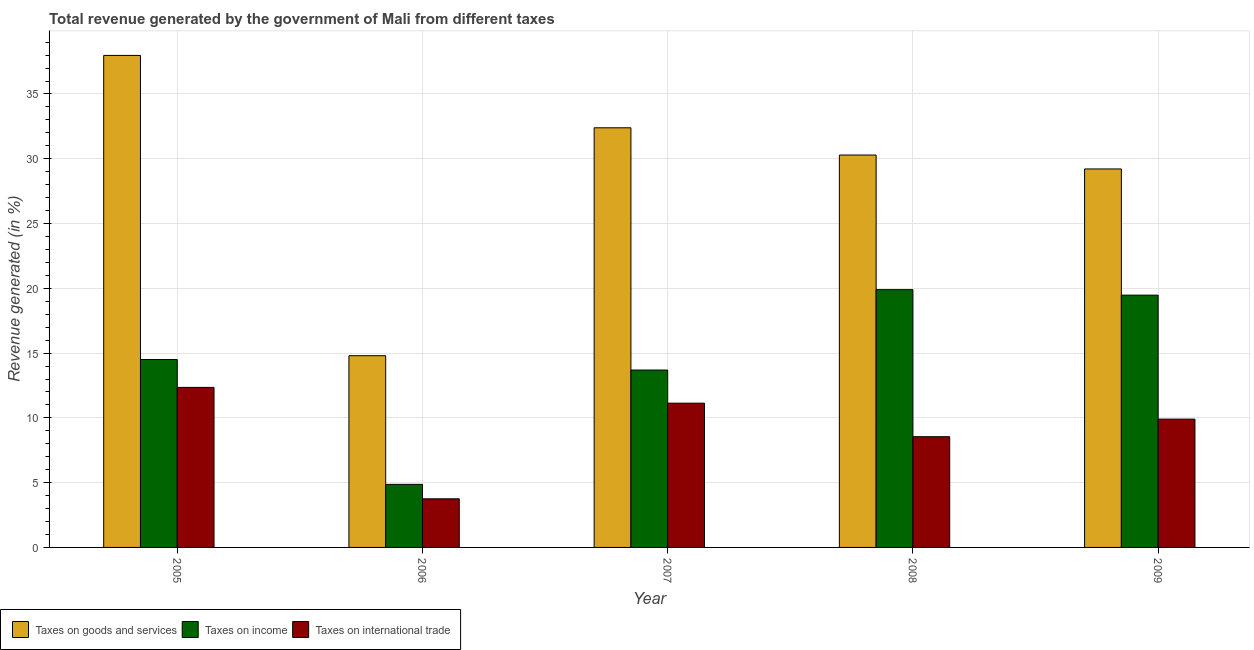How many different coloured bars are there?
Provide a short and direct response. 3. How many groups of bars are there?
Give a very brief answer. 5. Are the number of bars per tick equal to the number of legend labels?
Provide a short and direct response. Yes. Are the number of bars on each tick of the X-axis equal?
Offer a terse response. Yes. How many bars are there on the 4th tick from the left?
Your answer should be compact. 3. What is the label of the 3rd group of bars from the left?
Make the answer very short. 2007. What is the percentage of revenue generated by taxes on income in 2007?
Keep it short and to the point. 13.69. Across all years, what is the maximum percentage of revenue generated by taxes on income?
Ensure brevity in your answer.  19.9. Across all years, what is the minimum percentage of revenue generated by taxes on income?
Offer a very short reply. 4.87. In which year was the percentage of revenue generated by taxes on goods and services minimum?
Your response must be concise. 2006. What is the total percentage of revenue generated by taxes on income in the graph?
Provide a succinct answer. 72.44. What is the difference between the percentage of revenue generated by taxes on goods and services in 2006 and that in 2009?
Keep it short and to the point. -14.42. What is the difference between the percentage of revenue generated by taxes on income in 2007 and the percentage of revenue generated by taxes on goods and services in 2009?
Ensure brevity in your answer.  -5.78. What is the average percentage of revenue generated by taxes on goods and services per year?
Provide a short and direct response. 28.93. In the year 2006, what is the difference between the percentage of revenue generated by taxes on goods and services and percentage of revenue generated by tax on international trade?
Give a very brief answer. 0. What is the ratio of the percentage of revenue generated by taxes on goods and services in 2007 to that in 2009?
Your answer should be very brief. 1.11. What is the difference between the highest and the second highest percentage of revenue generated by taxes on goods and services?
Ensure brevity in your answer.  5.59. What is the difference between the highest and the lowest percentage of revenue generated by taxes on income?
Ensure brevity in your answer.  15.03. In how many years, is the percentage of revenue generated by tax on international trade greater than the average percentage of revenue generated by tax on international trade taken over all years?
Provide a short and direct response. 3. Is the sum of the percentage of revenue generated by taxes on goods and services in 2006 and 2009 greater than the maximum percentage of revenue generated by tax on international trade across all years?
Ensure brevity in your answer.  Yes. What does the 1st bar from the left in 2009 represents?
Provide a short and direct response. Taxes on goods and services. What does the 3rd bar from the right in 2006 represents?
Offer a very short reply. Taxes on goods and services. How many bars are there?
Offer a very short reply. 15. How many years are there in the graph?
Make the answer very short. 5. What is the difference between two consecutive major ticks on the Y-axis?
Your answer should be very brief. 5. Does the graph contain grids?
Give a very brief answer. Yes. Where does the legend appear in the graph?
Your answer should be very brief. Bottom left. How many legend labels are there?
Provide a succinct answer. 3. What is the title of the graph?
Make the answer very short. Total revenue generated by the government of Mali from different taxes. Does "Neonatal" appear as one of the legend labels in the graph?
Make the answer very short. No. What is the label or title of the X-axis?
Provide a short and direct response. Year. What is the label or title of the Y-axis?
Your answer should be compact. Revenue generated (in %). What is the Revenue generated (in %) in Taxes on goods and services in 2005?
Your response must be concise. 37.98. What is the Revenue generated (in %) of Taxes on income in 2005?
Make the answer very short. 14.51. What is the Revenue generated (in %) in Taxes on international trade in 2005?
Offer a terse response. 12.35. What is the Revenue generated (in %) of Taxes on goods and services in 2006?
Your answer should be very brief. 14.8. What is the Revenue generated (in %) of Taxes on income in 2006?
Give a very brief answer. 4.87. What is the Revenue generated (in %) in Taxes on international trade in 2006?
Provide a succinct answer. 3.75. What is the Revenue generated (in %) in Taxes on goods and services in 2007?
Your response must be concise. 32.39. What is the Revenue generated (in %) in Taxes on income in 2007?
Offer a terse response. 13.69. What is the Revenue generated (in %) in Taxes on international trade in 2007?
Provide a succinct answer. 11.14. What is the Revenue generated (in %) of Taxes on goods and services in 2008?
Provide a succinct answer. 30.29. What is the Revenue generated (in %) in Taxes on income in 2008?
Provide a succinct answer. 19.9. What is the Revenue generated (in %) in Taxes on international trade in 2008?
Ensure brevity in your answer.  8.55. What is the Revenue generated (in %) in Taxes on goods and services in 2009?
Ensure brevity in your answer.  29.21. What is the Revenue generated (in %) in Taxes on income in 2009?
Make the answer very short. 19.47. What is the Revenue generated (in %) in Taxes on international trade in 2009?
Your answer should be very brief. 9.9. Across all years, what is the maximum Revenue generated (in %) of Taxes on goods and services?
Ensure brevity in your answer.  37.98. Across all years, what is the maximum Revenue generated (in %) of Taxes on income?
Your answer should be very brief. 19.9. Across all years, what is the maximum Revenue generated (in %) in Taxes on international trade?
Your answer should be very brief. 12.35. Across all years, what is the minimum Revenue generated (in %) of Taxes on goods and services?
Provide a succinct answer. 14.8. Across all years, what is the minimum Revenue generated (in %) in Taxes on income?
Offer a very short reply. 4.87. Across all years, what is the minimum Revenue generated (in %) of Taxes on international trade?
Your answer should be very brief. 3.75. What is the total Revenue generated (in %) in Taxes on goods and services in the graph?
Keep it short and to the point. 144.67. What is the total Revenue generated (in %) of Taxes on income in the graph?
Offer a terse response. 72.44. What is the total Revenue generated (in %) in Taxes on international trade in the graph?
Ensure brevity in your answer.  45.69. What is the difference between the Revenue generated (in %) in Taxes on goods and services in 2005 and that in 2006?
Offer a terse response. 23.18. What is the difference between the Revenue generated (in %) of Taxes on income in 2005 and that in 2006?
Offer a terse response. 9.64. What is the difference between the Revenue generated (in %) in Taxes on international trade in 2005 and that in 2006?
Your answer should be very brief. 8.6. What is the difference between the Revenue generated (in %) in Taxes on goods and services in 2005 and that in 2007?
Offer a very short reply. 5.59. What is the difference between the Revenue generated (in %) of Taxes on income in 2005 and that in 2007?
Provide a short and direct response. 0.82. What is the difference between the Revenue generated (in %) in Taxes on international trade in 2005 and that in 2007?
Offer a terse response. 1.22. What is the difference between the Revenue generated (in %) of Taxes on goods and services in 2005 and that in 2008?
Offer a very short reply. 7.69. What is the difference between the Revenue generated (in %) of Taxes on income in 2005 and that in 2008?
Give a very brief answer. -5.39. What is the difference between the Revenue generated (in %) of Taxes on international trade in 2005 and that in 2008?
Give a very brief answer. 3.81. What is the difference between the Revenue generated (in %) of Taxes on goods and services in 2005 and that in 2009?
Your response must be concise. 8.76. What is the difference between the Revenue generated (in %) in Taxes on income in 2005 and that in 2009?
Your answer should be very brief. -4.97. What is the difference between the Revenue generated (in %) of Taxes on international trade in 2005 and that in 2009?
Offer a terse response. 2.45. What is the difference between the Revenue generated (in %) in Taxes on goods and services in 2006 and that in 2007?
Offer a terse response. -17.59. What is the difference between the Revenue generated (in %) of Taxes on income in 2006 and that in 2007?
Give a very brief answer. -8.82. What is the difference between the Revenue generated (in %) in Taxes on international trade in 2006 and that in 2007?
Offer a very short reply. -7.38. What is the difference between the Revenue generated (in %) of Taxes on goods and services in 2006 and that in 2008?
Ensure brevity in your answer.  -15.49. What is the difference between the Revenue generated (in %) of Taxes on income in 2006 and that in 2008?
Offer a very short reply. -15.03. What is the difference between the Revenue generated (in %) of Taxes on international trade in 2006 and that in 2008?
Provide a short and direct response. -4.79. What is the difference between the Revenue generated (in %) in Taxes on goods and services in 2006 and that in 2009?
Give a very brief answer. -14.42. What is the difference between the Revenue generated (in %) in Taxes on income in 2006 and that in 2009?
Your answer should be very brief. -14.61. What is the difference between the Revenue generated (in %) of Taxes on international trade in 2006 and that in 2009?
Give a very brief answer. -6.15. What is the difference between the Revenue generated (in %) in Taxes on goods and services in 2007 and that in 2008?
Your response must be concise. 2.1. What is the difference between the Revenue generated (in %) in Taxes on income in 2007 and that in 2008?
Your answer should be very brief. -6.2. What is the difference between the Revenue generated (in %) of Taxes on international trade in 2007 and that in 2008?
Offer a terse response. 2.59. What is the difference between the Revenue generated (in %) of Taxes on goods and services in 2007 and that in 2009?
Your answer should be very brief. 3.18. What is the difference between the Revenue generated (in %) in Taxes on income in 2007 and that in 2009?
Your answer should be compact. -5.78. What is the difference between the Revenue generated (in %) in Taxes on international trade in 2007 and that in 2009?
Give a very brief answer. 1.23. What is the difference between the Revenue generated (in %) in Taxes on goods and services in 2008 and that in 2009?
Offer a very short reply. 1.07. What is the difference between the Revenue generated (in %) in Taxes on income in 2008 and that in 2009?
Keep it short and to the point. 0.42. What is the difference between the Revenue generated (in %) of Taxes on international trade in 2008 and that in 2009?
Provide a short and direct response. -1.36. What is the difference between the Revenue generated (in %) of Taxes on goods and services in 2005 and the Revenue generated (in %) of Taxes on income in 2006?
Offer a terse response. 33.11. What is the difference between the Revenue generated (in %) in Taxes on goods and services in 2005 and the Revenue generated (in %) in Taxes on international trade in 2006?
Your answer should be very brief. 34.22. What is the difference between the Revenue generated (in %) of Taxes on income in 2005 and the Revenue generated (in %) of Taxes on international trade in 2006?
Offer a very short reply. 10.76. What is the difference between the Revenue generated (in %) in Taxes on goods and services in 2005 and the Revenue generated (in %) in Taxes on income in 2007?
Give a very brief answer. 24.29. What is the difference between the Revenue generated (in %) in Taxes on goods and services in 2005 and the Revenue generated (in %) in Taxes on international trade in 2007?
Make the answer very short. 26.84. What is the difference between the Revenue generated (in %) in Taxes on income in 2005 and the Revenue generated (in %) in Taxes on international trade in 2007?
Provide a short and direct response. 3.37. What is the difference between the Revenue generated (in %) in Taxes on goods and services in 2005 and the Revenue generated (in %) in Taxes on income in 2008?
Provide a short and direct response. 18.08. What is the difference between the Revenue generated (in %) in Taxes on goods and services in 2005 and the Revenue generated (in %) in Taxes on international trade in 2008?
Provide a short and direct response. 29.43. What is the difference between the Revenue generated (in %) of Taxes on income in 2005 and the Revenue generated (in %) of Taxes on international trade in 2008?
Your response must be concise. 5.96. What is the difference between the Revenue generated (in %) of Taxes on goods and services in 2005 and the Revenue generated (in %) of Taxes on income in 2009?
Keep it short and to the point. 18.5. What is the difference between the Revenue generated (in %) in Taxes on goods and services in 2005 and the Revenue generated (in %) in Taxes on international trade in 2009?
Your answer should be very brief. 28.07. What is the difference between the Revenue generated (in %) of Taxes on income in 2005 and the Revenue generated (in %) of Taxes on international trade in 2009?
Provide a succinct answer. 4.61. What is the difference between the Revenue generated (in %) of Taxes on goods and services in 2006 and the Revenue generated (in %) of Taxes on income in 2007?
Provide a succinct answer. 1.11. What is the difference between the Revenue generated (in %) of Taxes on goods and services in 2006 and the Revenue generated (in %) of Taxes on international trade in 2007?
Your response must be concise. 3.66. What is the difference between the Revenue generated (in %) of Taxes on income in 2006 and the Revenue generated (in %) of Taxes on international trade in 2007?
Provide a short and direct response. -6.27. What is the difference between the Revenue generated (in %) of Taxes on goods and services in 2006 and the Revenue generated (in %) of Taxes on income in 2008?
Offer a very short reply. -5.1. What is the difference between the Revenue generated (in %) in Taxes on goods and services in 2006 and the Revenue generated (in %) in Taxes on international trade in 2008?
Offer a very short reply. 6.25. What is the difference between the Revenue generated (in %) of Taxes on income in 2006 and the Revenue generated (in %) of Taxes on international trade in 2008?
Your answer should be very brief. -3.68. What is the difference between the Revenue generated (in %) of Taxes on goods and services in 2006 and the Revenue generated (in %) of Taxes on income in 2009?
Your answer should be very brief. -4.67. What is the difference between the Revenue generated (in %) in Taxes on goods and services in 2006 and the Revenue generated (in %) in Taxes on international trade in 2009?
Keep it short and to the point. 4.9. What is the difference between the Revenue generated (in %) of Taxes on income in 2006 and the Revenue generated (in %) of Taxes on international trade in 2009?
Provide a short and direct response. -5.04. What is the difference between the Revenue generated (in %) of Taxes on goods and services in 2007 and the Revenue generated (in %) of Taxes on income in 2008?
Your answer should be very brief. 12.5. What is the difference between the Revenue generated (in %) in Taxes on goods and services in 2007 and the Revenue generated (in %) in Taxes on international trade in 2008?
Offer a terse response. 23.85. What is the difference between the Revenue generated (in %) of Taxes on income in 2007 and the Revenue generated (in %) of Taxes on international trade in 2008?
Provide a short and direct response. 5.15. What is the difference between the Revenue generated (in %) in Taxes on goods and services in 2007 and the Revenue generated (in %) in Taxes on income in 2009?
Provide a short and direct response. 12.92. What is the difference between the Revenue generated (in %) in Taxes on goods and services in 2007 and the Revenue generated (in %) in Taxes on international trade in 2009?
Make the answer very short. 22.49. What is the difference between the Revenue generated (in %) in Taxes on income in 2007 and the Revenue generated (in %) in Taxes on international trade in 2009?
Your answer should be compact. 3.79. What is the difference between the Revenue generated (in %) of Taxes on goods and services in 2008 and the Revenue generated (in %) of Taxes on income in 2009?
Offer a very short reply. 10.81. What is the difference between the Revenue generated (in %) of Taxes on goods and services in 2008 and the Revenue generated (in %) of Taxes on international trade in 2009?
Your response must be concise. 20.39. What is the difference between the Revenue generated (in %) in Taxes on income in 2008 and the Revenue generated (in %) in Taxes on international trade in 2009?
Make the answer very short. 9.99. What is the average Revenue generated (in %) of Taxes on goods and services per year?
Offer a very short reply. 28.93. What is the average Revenue generated (in %) of Taxes on income per year?
Offer a very short reply. 14.49. What is the average Revenue generated (in %) in Taxes on international trade per year?
Your answer should be compact. 9.14. In the year 2005, what is the difference between the Revenue generated (in %) of Taxes on goods and services and Revenue generated (in %) of Taxes on income?
Give a very brief answer. 23.47. In the year 2005, what is the difference between the Revenue generated (in %) of Taxes on goods and services and Revenue generated (in %) of Taxes on international trade?
Keep it short and to the point. 25.62. In the year 2005, what is the difference between the Revenue generated (in %) of Taxes on income and Revenue generated (in %) of Taxes on international trade?
Ensure brevity in your answer.  2.15. In the year 2006, what is the difference between the Revenue generated (in %) in Taxes on goods and services and Revenue generated (in %) in Taxes on income?
Provide a short and direct response. 9.93. In the year 2006, what is the difference between the Revenue generated (in %) of Taxes on goods and services and Revenue generated (in %) of Taxes on international trade?
Offer a terse response. 11.05. In the year 2006, what is the difference between the Revenue generated (in %) of Taxes on income and Revenue generated (in %) of Taxes on international trade?
Your answer should be compact. 1.11. In the year 2007, what is the difference between the Revenue generated (in %) of Taxes on goods and services and Revenue generated (in %) of Taxes on income?
Keep it short and to the point. 18.7. In the year 2007, what is the difference between the Revenue generated (in %) of Taxes on goods and services and Revenue generated (in %) of Taxes on international trade?
Keep it short and to the point. 21.26. In the year 2007, what is the difference between the Revenue generated (in %) of Taxes on income and Revenue generated (in %) of Taxes on international trade?
Offer a very short reply. 2.56. In the year 2008, what is the difference between the Revenue generated (in %) of Taxes on goods and services and Revenue generated (in %) of Taxes on income?
Give a very brief answer. 10.39. In the year 2008, what is the difference between the Revenue generated (in %) of Taxes on goods and services and Revenue generated (in %) of Taxes on international trade?
Offer a terse response. 21.74. In the year 2008, what is the difference between the Revenue generated (in %) of Taxes on income and Revenue generated (in %) of Taxes on international trade?
Give a very brief answer. 11.35. In the year 2009, what is the difference between the Revenue generated (in %) in Taxes on goods and services and Revenue generated (in %) in Taxes on income?
Make the answer very short. 9.74. In the year 2009, what is the difference between the Revenue generated (in %) in Taxes on goods and services and Revenue generated (in %) in Taxes on international trade?
Provide a short and direct response. 19.31. In the year 2009, what is the difference between the Revenue generated (in %) of Taxes on income and Revenue generated (in %) of Taxes on international trade?
Keep it short and to the point. 9.57. What is the ratio of the Revenue generated (in %) of Taxes on goods and services in 2005 to that in 2006?
Your answer should be very brief. 2.57. What is the ratio of the Revenue generated (in %) in Taxes on income in 2005 to that in 2006?
Make the answer very short. 2.98. What is the ratio of the Revenue generated (in %) of Taxes on international trade in 2005 to that in 2006?
Keep it short and to the point. 3.29. What is the ratio of the Revenue generated (in %) of Taxes on goods and services in 2005 to that in 2007?
Provide a succinct answer. 1.17. What is the ratio of the Revenue generated (in %) of Taxes on income in 2005 to that in 2007?
Keep it short and to the point. 1.06. What is the ratio of the Revenue generated (in %) in Taxes on international trade in 2005 to that in 2007?
Offer a terse response. 1.11. What is the ratio of the Revenue generated (in %) in Taxes on goods and services in 2005 to that in 2008?
Offer a terse response. 1.25. What is the ratio of the Revenue generated (in %) in Taxes on income in 2005 to that in 2008?
Offer a terse response. 0.73. What is the ratio of the Revenue generated (in %) of Taxes on international trade in 2005 to that in 2008?
Offer a terse response. 1.45. What is the ratio of the Revenue generated (in %) of Taxes on goods and services in 2005 to that in 2009?
Your response must be concise. 1.3. What is the ratio of the Revenue generated (in %) of Taxes on income in 2005 to that in 2009?
Offer a terse response. 0.74. What is the ratio of the Revenue generated (in %) of Taxes on international trade in 2005 to that in 2009?
Your response must be concise. 1.25. What is the ratio of the Revenue generated (in %) of Taxes on goods and services in 2006 to that in 2007?
Ensure brevity in your answer.  0.46. What is the ratio of the Revenue generated (in %) of Taxes on income in 2006 to that in 2007?
Ensure brevity in your answer.  0.36. What is the ratio of the Revenue generated (in %) of Taxes on international trade in 2006 to that in 2007?
Provide a short and direct response. 0.34. What is the ratio of the Revenue generated (in %) in Taxes on goods and services in 2006 to that in 2008?
Provide a short and direct response. 0.49. What is the ratio of the Revenue generated (in %) in Taxes on income in 2006 to that in 2008?
Provide a short and direct response. 0.24. What is the ratio of the Revenue generated (in %) of Taxes on international trade in 2006 to that in 2008?
Provide a short and direct response. 0.44. What is the ratio of the Revenue generated (in %) in Taxes on goods and services in 2006 to that in 2009?
Offer a very short reply. 0.51. What is the ratio of the Revenue generated (in %) in Taxes on income in 2006 to that in 2009?
Ensure brevity in your answer.  0.25. What is the ratio of the Revenue generated (in %) of Taxes on international trade in 2006 to that in 2009?
Keep it short and to the point. 0.38. What is the ratio of the Revenue generated (in %) of Taxes on goods and services in 2007 to that in 2008?
Make the answer very short. 1.07. What is the ratio of the Revenue generated (in %) in Taxes on income in 2007 to that in 2008?
Give a very brief answer. 0.69. What is the ratio of the Revenue generated (in %) in Taxes on international trade in 2007 to that in 2008?
Offer a terse response. 1.3. What is the ratio of the Revenue generated (in %) of Taxes on goods and services in 2007 to that in 2009?
Your response must be concise. 1.11. What is the ratio of the Revenue generated (in %) of Taxes on income in 2007 to that in 2009?
Make the answer very short. 0.7. What is the ratio of the Revenue generated (in %) of Taxes on international trade in 2007 to that in 2009?
Ensure brevity in your answer.  1.12. What is the ratio of the Revenue generated (in %) in Taxes on goods and services in 2008 to that in 2009?
Provide a succinct answer. 1.04. What is the ratio of the Revenue generated (in %) in Taxes on income in 2008 to that in 2009?
Give a very brief answer. 1.02. What is the ratio of the Revenue generated (in %) in Taxes on international trade in 2008 to that in 2009?
Give a very brief answer. 0.86. What is the difference between the highest and the second highest Revenue generated (in %) in Taxes on goods and services?
Offer a terse response. 5.59. What is the difference between the highest and the second highest Revenue generated (in %) of Taxes on income?
Give a very brief answer. 0.42. What is the difference between the highest and the second highest Revenue generated (in %) in Taxes on international trade?
Provide a short and direct response. 1.22. What is the difference between the highest and the lowest Revenue generated (in %) of Taxes on goods and services?
Provide a short and direct response. 23.18. What is the difference between the highest and the lowest Revenue generated (in %) of Taxes on income?
Your answer should be very brief. 15.03. What is the difference between the highest and the lowest Revenue generated (in %) in Taxes on international trade?
Provide a succinct answer. 8.6. 